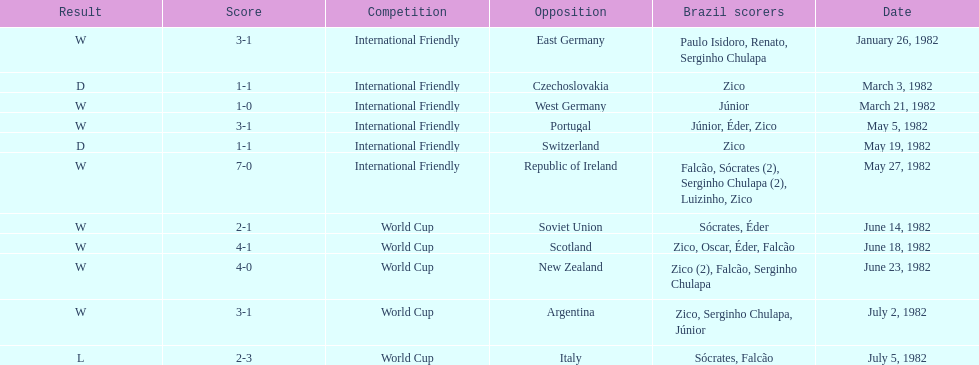What was the total number of losses brazil suffered? 1. 